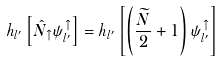Convert formula to latex. <formula><loc_0><loc_0><loc_500><loc_500>h _ { l ^ { \prime } } \left [ \hat { N } _ { \uparrow } \psi _ { l ^ { \prime } } ^ { \uparrow } \right ] = h _ { l ^ { \prime } } \left [ \left ( \frac { \widetilde { N } } { 2 } + 1 \right ) \psi _ { l ^ { \prime } } ^ { \uparrow } \right ]</formula> 